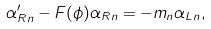<formula> <loc_0><loc_0><loc_500><loc_500>\alpha _ { R n } ^ { \prime } - F ( \phi ) \alpha _ { R n } = - m _ { n } \alpha _ { L n } ,</formula> 